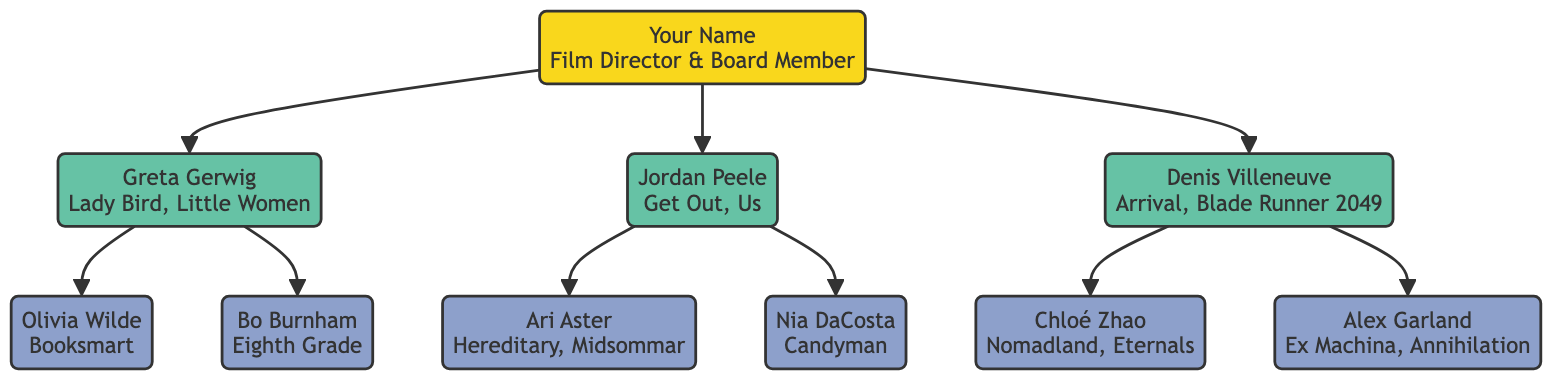What is the main role of "Your Name"? In the diagram, "Your Name" is labeled as a "Film Director & Board Member," indicating their primary role within the family tree.
Answer: Film Director & Board Member How many directors did "Your Name" mentor? By counting the directed nodes stemming from "Your Name," we can see there are three directors: Greta Gerwig, Jordan Peele, and Denis Villeneuve.
Answer: 3 Which film is associated with Greta Gerwig? Looking at the node for Greta Gerwig, the diagram lists two films: "Lady Bird" and "Little Women.” Therefore, either of these films is correct as an example.
Answer: Lady Bird Who influenced Olivia Wilde? Following the diagram from "Greta Gerwig" to "Olivia Wilde", indicates that Greta Gerwig is the mentor here, making her the influencer of Olivia Wilde.
Answer: Greta Gerwig What kind of films did Jordan Peele create? The films associated with Jordan Peele are "Get Out" and "Us," which are explicitly stated near his node in the diagram.
Answer: Get Out, Us What influence did Ari Aster describe? The diagram notes that Ari Aster was influenced by Jordan Peele, specifically describing an "Innovative approach to blending horror with social commentary." This statement conveys Ari Aster's connection and influence description.
Answer: Innovative approach to blending horror with social commentary Which director has the most influenced directors listed? By examining the connections stemming from each mentor, Denis Villeneuve, Greta Gerwig, and Jordan Peele each lead to two influenced directors. However, since the focus is on the quantity of connections, they are all tied with two each.
Answer: 2 Which film did Bo Burnham direct? The node connected to Bo Burnham clearly states his associated film, "Eighth Grade," thereby allowing us to directly cite it as his work.
Answer: Eighth Grade What theme is addressed in Nia DaCosta's "Candyman"? The diagram details that Nia DaCosta utilizes horror to address themes of systemic racism and history, which provides context about her film.
Answer: Systemic racism and history 